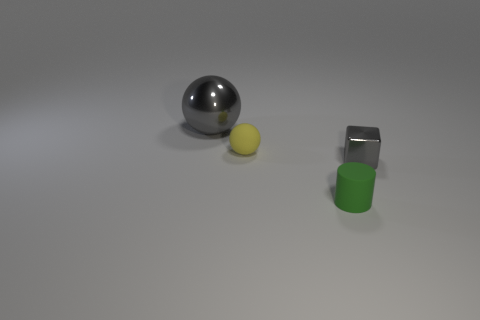Add 2 brown matte cylinders. How many objects exist? 6 Add 2 tiny things. How many tiny things are left? 5 Add 1 small matte cylinders. How many small matte cylinders exist? 2 Subtract 0 blue cubes. How many objects are left? 4 Subtract all small cylinders. Subtract all cubes. How many objects are left? 2 